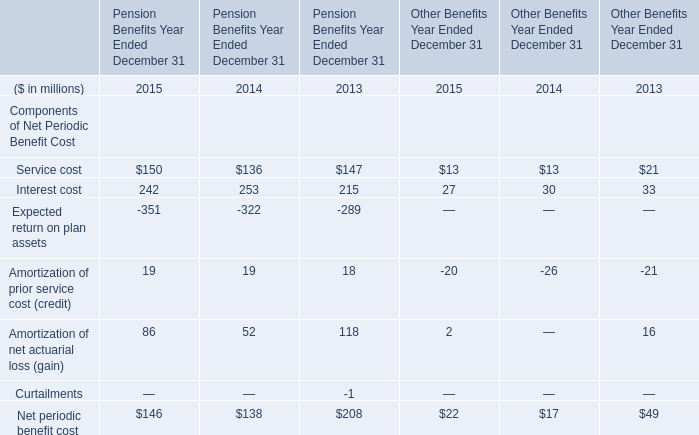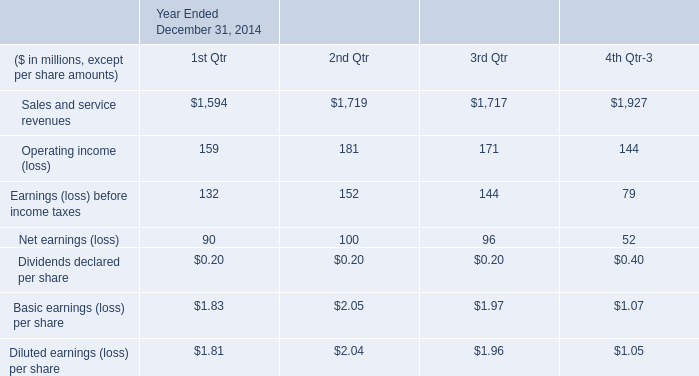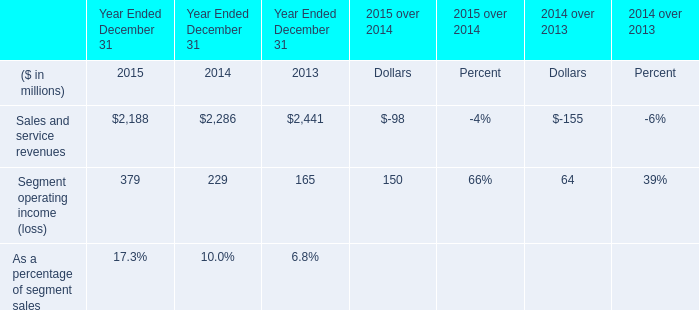What is the proportion of all elements for Pension Benefits Year Ended December 31 that are greater than 100 to the total amount of elements, in 2013? 
Computations: (((147 + 215) + 118) / 208)
Answer: 2.30769. 